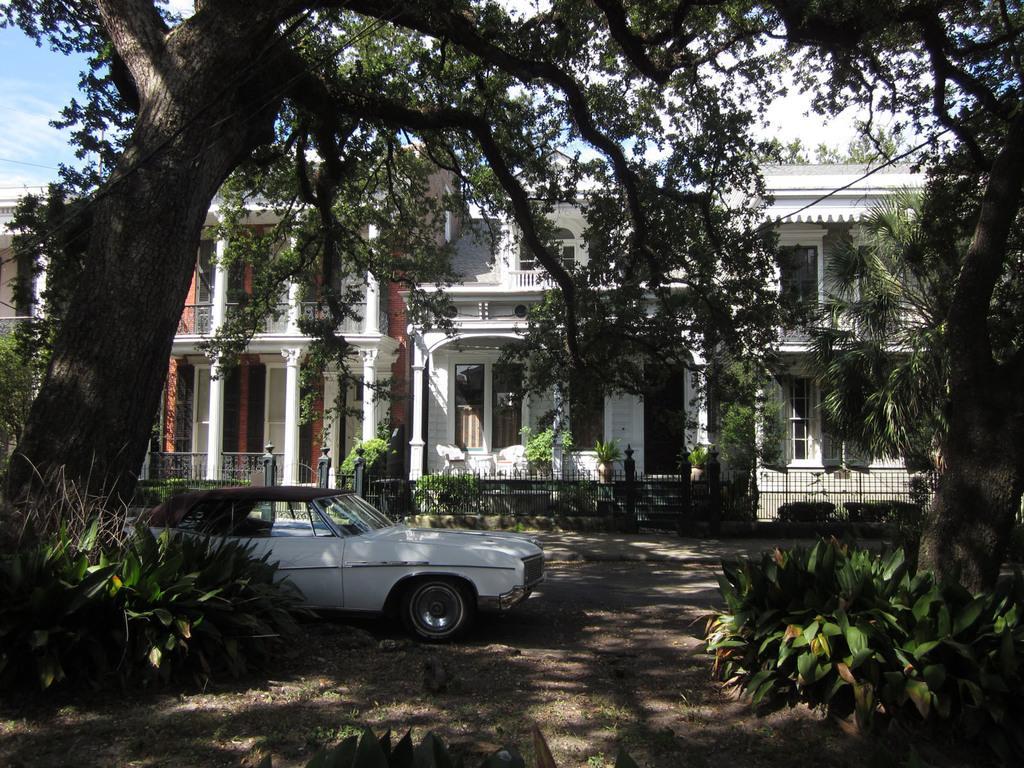How would you summarize this image in a sentence or two? In this picture we can see plants, trees and car. In the background of the image we can see fence, railings, plants, pillars, buildings and sky. 